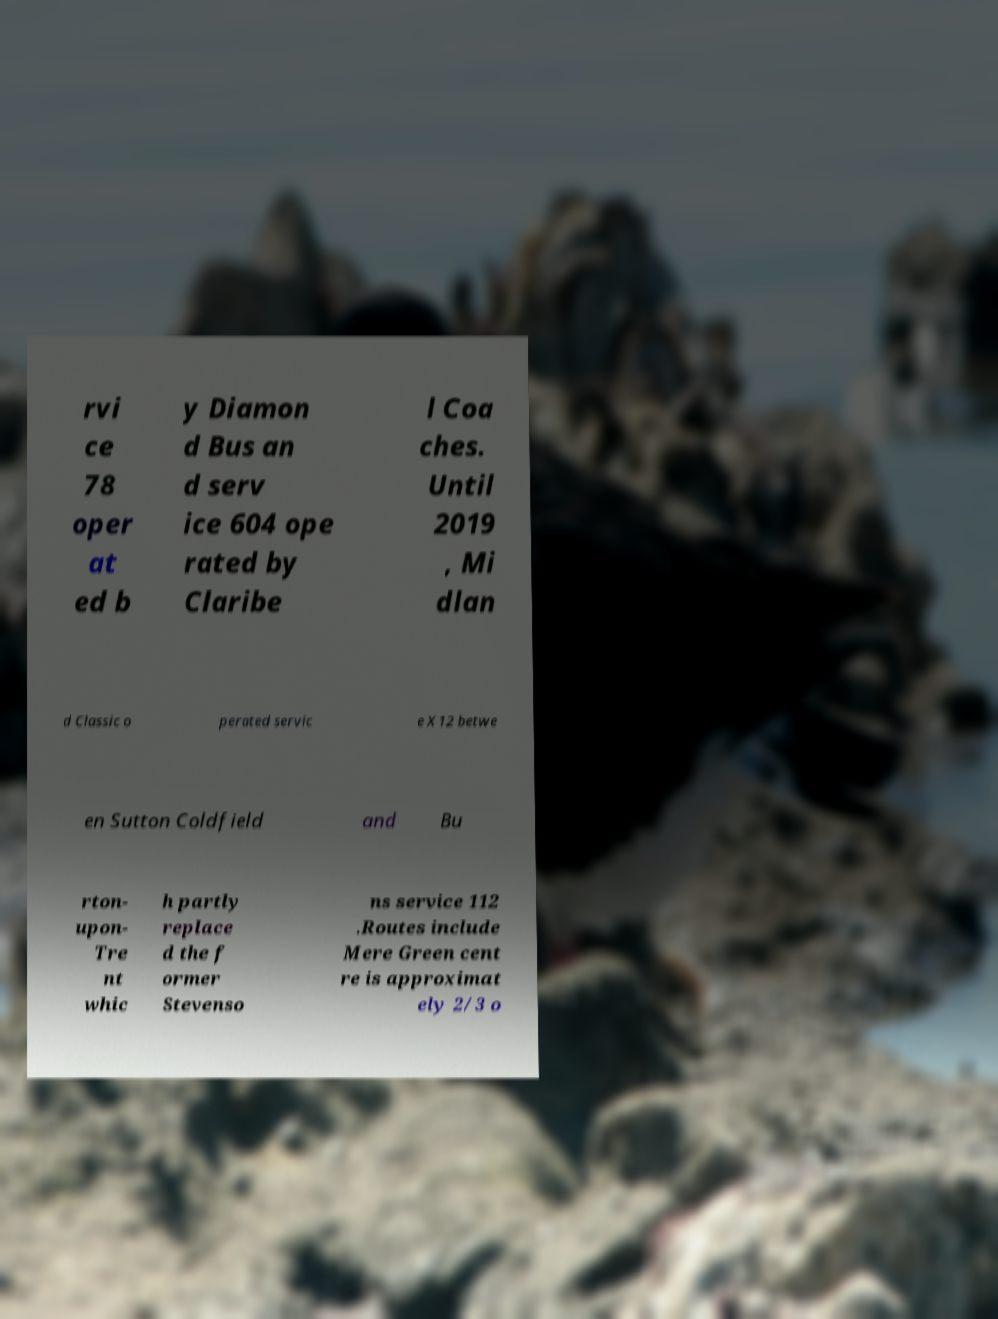There's text embedded in this image that I need extracted. Can you transcribe it verbatim? rvi ce 78 oper at ed b y Diamon d Bus an d serv ice 604 ope rated by Claribe l Coa ches. Until 2019 , Mi dlan d Classic o perated servic e X12 betwe en Sutton Coldfield and Bu rton- upon- Tre nt whic h partly replace d the f ormer Stevenso ns service 112 .Routes include Mere Green cent re is approximat ely 2/3 o 